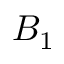Convert formula to latex. <formula><loc_0><loc_0><loc_500><loc_500>B _ { 1 }</formula> 